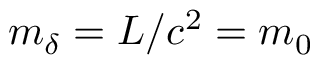Convert formula to latex. <formula><loc_0><loc_0><loc_500><loc_500>m _ { \delta } = { L } / { c ^ { 2 } } = m _ { 0 }</formula> 